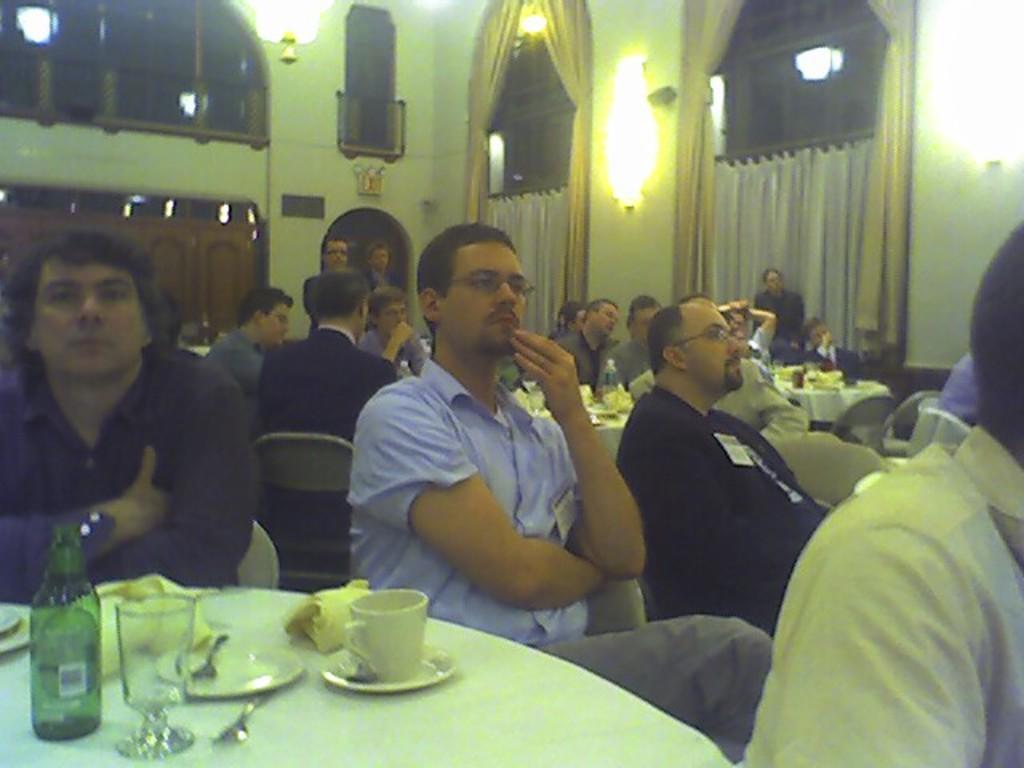Could you give a brief overview of what you see in this image? In the image we can see there are people sitting on the chair and there is wine bottle, wine glass, cup and saucer kept on the table. Behind there are other people sitting on the chairs and there are lights on the wall. There are curtains on the window. 